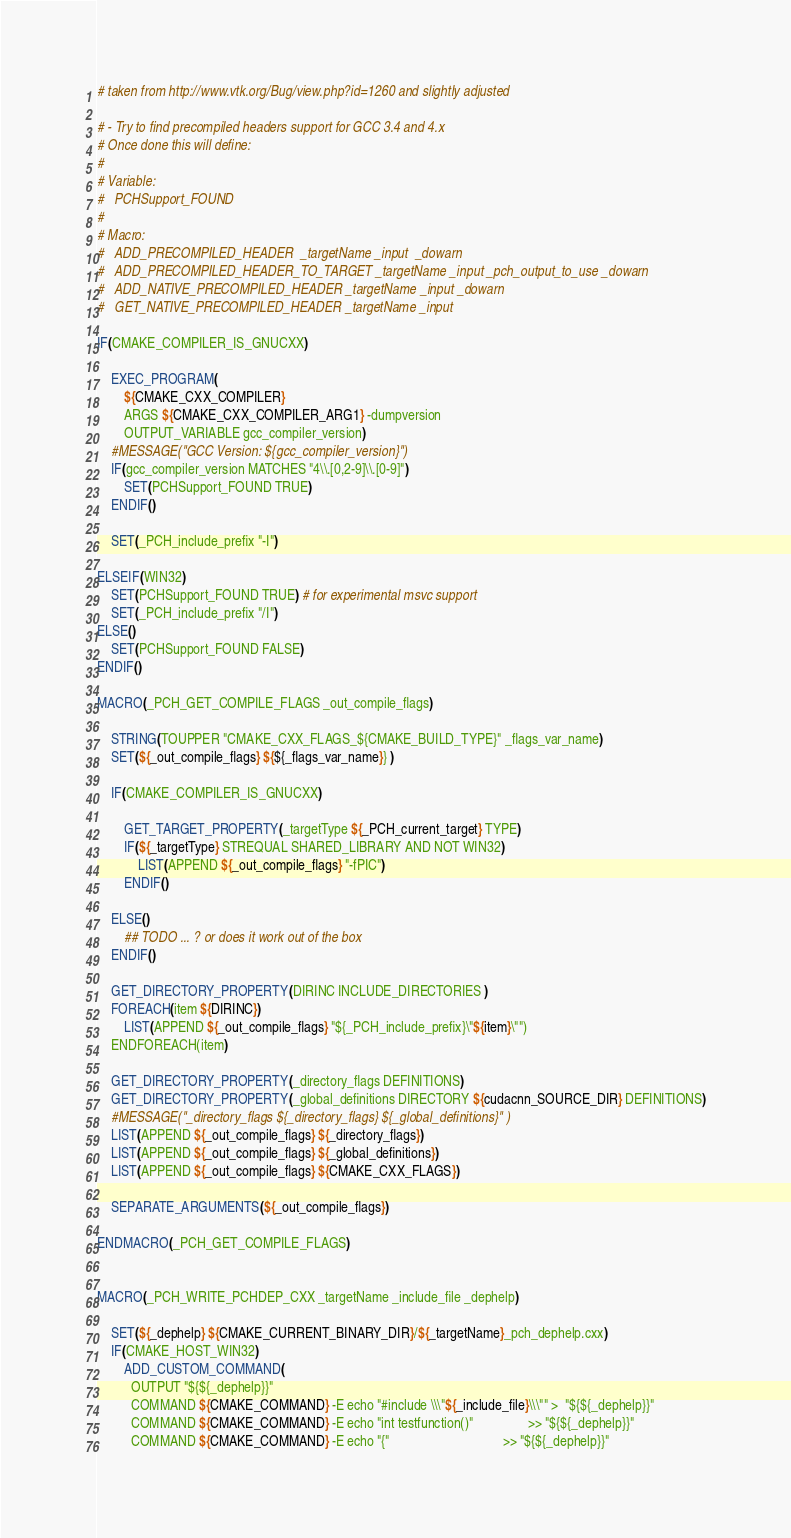<code> <loc_0><loc_0><loc_500><loc_500><_CMake_># taken from http://www.vtk.org/Bug/view.php?id=1260 and slightly adjusted

# - Try to find precompiled headers support for GCC 3.4 and 4.x
# Once done this will define:
#
# Variable:
#   PCHSupport_FOUND
#
# Macro:
#   ADD_PRECOMPILED_HEADER  _targetName _input  _dowarn
#   ADD_PRECOMPILED_HEADER_TO_TARGET _targetName _input _pch_output_to_use _dowarn
#   ADD_NATIVE_PRECOMPILED_HEADER _targetName _input _dowarn
#   GET_NATIVE_PRECOMPILED_HEADER _targetName _input

IF(CMAKE_COMPILER_IS_GNUCXX)

    EXEC_PROGRAM(
        ${CMAKE_CXX_COMPILER}
        ARGS ${CMAKE_CXX_COMPILER_ARG1} -dumpversion
        OUTPUT_VARIABLE gcc_compiler_version)
    #MESSAGE("GCC Version: ${gcc_compiler_version}")
    IF(gcc_compiler_version MATCHES "4\\.[0,2-9]\\.[0-9]")
        SET(PCHSupport_FOUND TRUE)
    ENDIF()

    SET(_PCH_include_prefix "-I")

ELSEIF(WIN32)
    SET(PCHSupport_FOUND TRUE) # for experimental msvc support
    SET(_PCH_include_prefix "/I")
ELSE()
    SET(PCHSupport_FOUND FALSE)
ENDIF()

MACRO(_PCH_GET_COMPILE_FLAGS _out_compile_flags)

    STRING(TOUPPER "CMAKE_CXX_FLAGS_${CMAKE_BUILD_TYPE}" _flags_var_name)
    SET(${_out_compile_flags} ${${_flags_var_name}} )

    IF(CMAKE_COMPILER_IS_GNUCXX)

        GET_TARGET_PROPERTY(_targetType ${_PCH_current_target} TYPE)
        IF(${_targetType} STREQUAL SHARED_LIBRARY AND NOT WIN32)
            LIST(APPEND ${_out_compile_flags} "-fPIC")
        ENDIF()

    ELSE()
        ## TODO ... ? or does it work out of the box
    ENDIF()

    GET_DIRECTORY_PROPERTY(DIRINC INCLUDE_DIRECTORIES )
    FOREACH(item ${DIRINC})
        LIST(APPEND ${_out_compile_flags} "${_PCH_include_prefix}\"${item}\"")
    ENDFOREACH(item)

    GET_DIRECTORY_PROPERTY(_directory_flags DEFINITIONS)
    GET_DIRECTORY_PROPERTY(_global_definitions DIRECTORY ${cudacnn_SOURCE_DIR} DEFINITIONS)
    #MESSAGE("_directory_flags ${_directory_flags} ${_global_definitions}" )
    LIST(APPEND ${_out_compile_flags} ${_directory_flags})
    LIST(APPEND ${_out_compile_flags} ${_global_definitions})
    LIST(APPEND ${_out_compile_flags} ${CMAKE_CXX_FLAGS})

    SEPARATE_ARGUMENTS(${_out_compile_flags})

ENDMACRO(_PCH_GET_COMPILE_FLAGS)


MACRO(_PCH_WRITE_PCHDEP_CXX _targetName _include_file _dephelp)

    SET(${_dephelp} ${CMAKE_CURRENT_BINARY_DIR}/${_targetName}_pch_dephelp.cxx)
    IF(CMAKE_HOST_WIN32)
        ADD_CUSTOM_COMMAND(
          OUTPUT "${${_dephelp}}"
          COMMAND ${CMAKE_COMMAND} -E echo "#include \\\"${_include_file}\\\"" >  "${${_dephelp}}"
          COMMAND ${CMAKE_COMMAND} -E echo "int testfunction()"                >> "${${_dephelp}}"
          COMMAND ${CMAKE_COMMAND} -E echo "{"                                 >> "${${_dephelp}}"</code> 